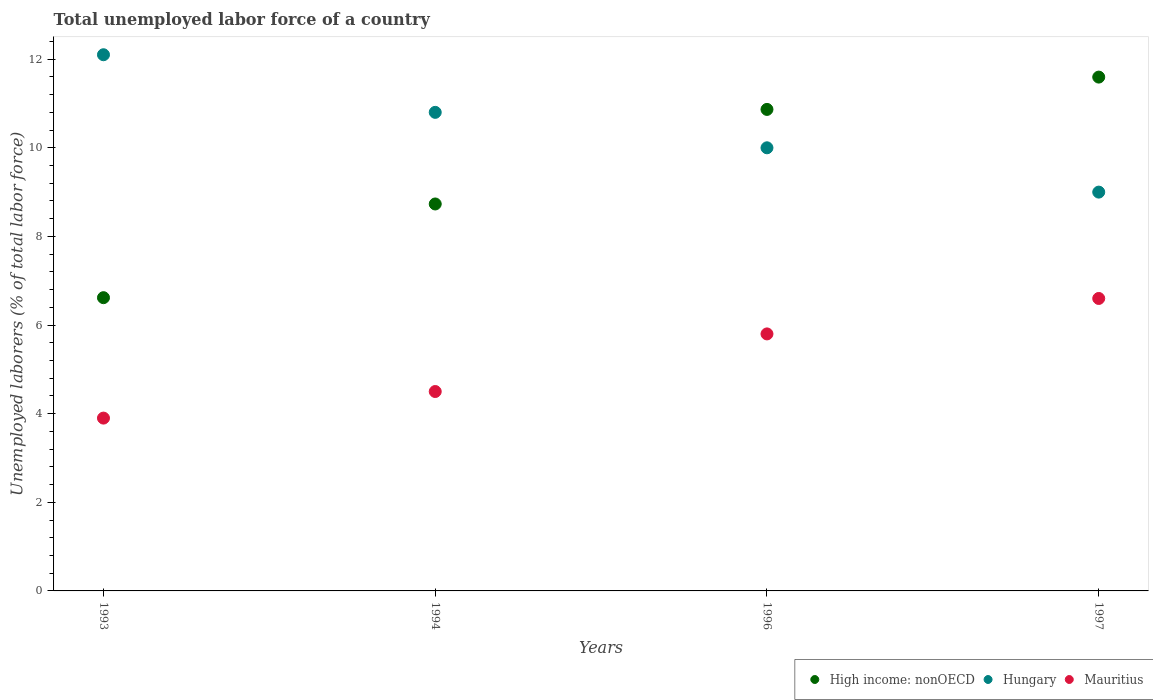How many different coloured dotlines are there?
Give a very brief answer. 3. Is the number of dotlines equal to the number of legend labels?
Your answer should be compact. Yes. What is the total unemployed labor force in High income: nonOECD in 1993?
Your answer should be compact. 6.62. Across all years, what is the maximum total unemployed labor force in Hungary?
Provide a short and direct response. 12.1. Across all years, what is the minimum total unemployed labor force in Mauritius?
Give a very brief answer. 3.9. In which year was the total unemployed labor force in Mauritius minimum?
Keep it short and to the point. 1993. What is the total total unemployed labor force in Hungary in the graph?
Your answer should be compact. 41.9. What is the difference between the total unemployed labor force in High income: nonOECD in 1994 and that in 1996?
Offer a terse response. -2.13. What is the difference between the total unemployed labor force in High income: nonOECD in 1994 and the total unemployed labor force in Mauritius in 1997?
Keep it short and to the point. 2.13. What is the average total unemployed labor force in High income: nonOECD per year?
Give a very brief answer. 9.45. In the year 1993, what is the difference between the total unemployed labor force in High income: nonOECD and total unemployed labor force in Hungary?
Keep it short and to the point. -5.48. In how many years, is the total unemployed labor force in Mauritius greater than 7.2 %?
Offer a terse response. 0. What is the ratio of the total unemployed labor force in Hungary in 1993 to that in 1994?
Ensure brevity in your answer.  1.12. Is the total unemployed labor force in High income: nonOECD in 1993 less than that in 1994?
Ensure brevity in your answer.  Yes. Is the difference between the total unemployed labor force in High income: nonOECD in 1993 and 1996 greater than the difference between the total unemployed labor force in Hungary in 1993 and 1996?
Provide a succinct answer. No. What is the difference between the highest and the second highest total unemployed labor force in Mauritius?
Offer a terse response. 0.8. What is the difference between the highest and the lowest total unemployed labor force in Hungary?
Make the answer very short. 3.1. In how many years, is the total unemployed labor force in Hungary greater than the average total unemployed labor force in Hungary taken over all years?
Ensure brevity in your answer.  2. Is the sum of the total unemployed labor force in Mauritius in 1993 and 1997 greater than the maximum total unemployed labor force in Hungary across all years?
Your answer should be very brief. No. Is it the case that in every year, the sum of the total unemployed labor force in High income: nonOECD and total unemployed labor force in Hungary  is greater than the total unemployed labor force in Mauritius?
Ensure brevity in your answer.  Yes. Does the total unemployed labor force in Hungary monotonically increase over the years?
Your answer should be very brief. No. Is the total unemployed labor force in Hungary strictly less than the total unemployed labor force in Mauritius over the years?
Give a very brief answer. No. How many dotlines are there?
Offer a very short reply. 3. How many years are there in the graph?
Provide a succinct answer. 4. What is the difference between two consecutive major ticks on the Y-axis?
Provide a succinct answer. 2. Are the values on the major ticks of Y-axis written in scientific E-notation?
Provide a short and direct response. No. Does the graph contain grids?
Your answer should be compact. No. Where does the legend appear in the graph?
Make the answer very short. Bottom right. What is the title of the graph?
Give a very brief answer. Total unemployed labor force of a country. Does "Niger" appear as one of the legend labels in the graph?
Your answer should be very brief. No. What is the label or title of the Y-axis?
Provide a short and direct response. Unemployed laborers (% of total labor force). What is the Unemployed laborers (% of total labor force) in High income: nonOECD in 1993?
Ensure brevity in your answer.  6.62. What is the Unemployed laborers (% of total labor force) of Hungary in 1993?
Provide a succinct answer. 12.1. What is the Unemployed laborers (% of total labor force) in Mauritius in 1993?
Give a very brief answer. 3.9. What is the Unemployed laborers (% of total labor force) of High income: nonOECD in 1994?
Keep it short and to the point. 8.73. What is the Unemployed laborers (% of total labor force) in Hungary in 1994?
Ensure brevity in your answer.  10.8. What is the Unemployed laborers (% of total labor force) of Mauritius in 1994?
Give a very brief answer. 4.5. What is the Unemployed laborers (% of total labor force) of High income: nonOECD in 1996?
Keep it short and to the point. 10.87. What is the Unemployed laborers (% of total labor force) in Mauritius in 1996?
Offer a terse response. 5.8. What is the Unemployed laborers (% of total labor force) of High income: nonOECD in 1997?
Keep it short and to the point. 11.6. What is the Unemployed laborers (% of total labor force) of Mauritius in 1997?
Your answer should be very brief. 6.6. Across all years, what is the maximum Unemployed laborers (% of total labor force) in High income: nonOECD?
Provide a short and direct response. 11.6. Across all years, what is the maximum Unemployed laborers (% of total labor force) in Hungary?
Make the answer very short. 12.1. Across all years, what is the maximum Unemployed laborers (% of total labor force) in Mauritius?
Provide a short and direct response. 6.6. Across all years, what is the minimum Unemployed laborers (% of total labor force) of High income: nonOECD?
Your response must be concise. 6.62. Across all years, what is the minimum Unemployed laborers (% of total labor force) in Mauritius?
Make the answer very short. 3.9. What is the total Unemployed laborers (% of total labor force) of High income: nonOECD in the graph?
Offer a very short reply. 37.81. What is the total Unemployed laborers (% of total labor force) of Hungary in the graph?
Make the answer very short. 41.9. What is the total Unemployed laborers (% of total labor force) in Mauritius in the graph?
Your answer should be very brief. 20.8. What is the difference between the Unemployed laborers (% of total labor force) of High income: nonOECD in 1993 and that in 1994?
Your response must be concise. -2.11. What is the difference between the Unemployed laborers (% of total labor force) in Hungary in 1993 and that in 1994?
Give a very brief answer. 1.3. What is the difference between the Unemployed laborers (% of total labor force) in Mauritius in 1993 and that in 1994?
Offer a very short reply. -0.6. What is the difference between the Unemployed laborers (% of total labor force) in High income: nonOECD in 1993 and that in 1996?
Provide a short and direct response. -4.25. What is the difference between the Unemployed laborers (% of total labor force) in Hungary in 1993 and that in 1996?
Your answer should be very brief. 2.1. What is the difference between the Unemployed laborers (% of total labor force) in High income: nonOECD in 1993 and that in 1997?
Give a very brief answer. -4.98. What is the difference between the Unemployed laborers (% of total labor force) of Mauritius in 1993 and that in 1997?
Provide a short and direct response. -2.7. What is the difference between the Unemployed laborers (% of total labor force) in High income: nonOECD in 1994 and that in 1996?
Provide a short and direct response. -2.13. What is the difference between the Unemployed laborers (% of total labor force) of Hungary in 1994 and that in 1996?
Keep it short and to the point. 0.8. What is the difference between the Unemployed laborers (% of total labor force) in High income: nonOECD in 1994 and that in 1997?
Offer a terse response. -2.86. What is the difference between the Unemployed laborers (% of total labor force) in Mauritius in 1994 and that in 1997?
Ensure brevity in your answer.  -2.1. What is the difference between the Unemployed laborers (% of total labor force) of High income: nonOECD in 1996 and that in 1997?
Offer a terse response. -0.73. What is the difference between the Unemployed laborers (% of total labor force) in Hungary in 1996 and that in 1997?
Give a very brief answer. 1. What is the difference between the Unemployed laborers (% of total labor force) of High income: nonOECD in 1993 and the Unemployed laborers (% of total labor force) of Hungary in 1994?
Provide a succinct answer. -4.18. What is the difference between the Unemployed laborers (% of total labor force) of High income: nonOECD in 1993 and the Unemployed laborers (% of total labor force) of Mauritius in 1994?
Provide a short and direct response. 2.12. What is the difference between the Unemployed laborers (% of total labor force) of High income: nonOECD in 1993 and the Unemployed laborers (% of total labor force) of Hungary in 1996?
Keep it short and to the point. -3.38. What is the difference between the Unemployed laborers (% of total labor force) in High income: nonOECD in 1993 and the Unemployed laborers (% of total labor force) in Mauritius in 1996?
Provide a succinct answer. 0.82. What is the difference between the Unemployed laborers (% of total labor force) of Hungary in 1993 and the Unemployed laborers (% of total labor force) of Mauritius in 1996?
Your answer should be compact. 6.3. What is the difference between the Unemployed laborers (% of total labor force) of High income: nonOECD in 1993 and the Unemployed laborers (% of total labor force) of Hungary in 1997?
Your answer should be compact. -2.38. What is the difference between the Unemployed laborers (% of total labor force) in High income: nonOECD in 1993 and the Unemployed laborers (% of total labor force) in Mauritius in 1997?
Give a very brief answer. 0.02. What is the difference between the Unemployed laborers (% of total labor force) in Hungary in 1993 and the Unemployed laborers (% of total labor force) in Mauritius in 1997?
Provide a short and direct response. 5.5. What is the difference between the Unemployed laborers (% of total labor force) of High income: nonOECD in 1994 and the Unemployed laborers (% of total labor force) of Hungary in 1996?
Offer a very short reply. -1.27. What is the difference between the Unemployed laborers (% of total labor force) in High income: nonOECD in 1994 and the Unemployed laborers (% of total labor force) in Mauritius in 1996?
Your answer should be very brief. 2.93. What is the difference between the Unemployed laborers (% of total labor force) in High income: nonOECD in 1994 and the Unemployed laborers (% of total labor force) in Hungary in 1997?
Offer a terse response. -0.27. What is the difference between the Unemployed laborers (% of total labor force) of High income: nonOECD in 1994 and the Unemployed laborers (% of total labor force) of Mauritius in 1997?
Your answer should be very brief. 2.13. What is the difference between the Unemployed laborers (% of total labor force) of Hungary in 1994 and the Unemployed laborers (% of total labor force) of Mauritius in 1997?
Your answer should be compact. 4.2. What is the difference between the Unemployed laborers (% of total labor force) in High income: nonOECD in 1996 and the Unemployed laborers (% of total labor force) in Hungary in 1997?
Give a very brief answer. 1.87. What is the difference between the Unemployed laborers (% of total labor force) in High income: nonOECD in 1996 and the Unemployed laborers (% of total labor force) in Mauritius in 1997?
Provide a short and direct response. 4.27. What is the average Unemployed laborers (% of total labor force) in High income: nonOECD per year?
Offer a very short reply. 9.45. What is the average Unemployed laborers (% of total labor force) of Hungary per year?
Make the answer very short. 10.47. In the year 1993, what is the difference between the Unemployed laborers (% of total labor force) in High income: nonOECD and Unemployed laborers (% of total labor force) in Hungary?
Offer a terse response. -5.48. In the year 1993, what is the difference between the Unemployed laborers (% of total labor force) of High income: nonOECD and Unemployed laborers (% of total labor force) of Mauritius?
Provide a short and direct response. 2.72. In the year 1994, what is the difference between the Unemployed laborers (% of total labor force) in High income: nonOECD and Unemployed laborers (% of total labor force) in Hungary?
Offer a terse response. -2.07. In the year 1994, what is the difference between the Unemployed laborers (% of total labor force) in High income: nonOECD and Unemployed laborers (% of total labor force) in Mauritius?
Offer a terse response. 4.23. In the year 1994, what is the difference between the Unemployed laborers (% of total labor force) of Hungary and Unemployed laborers (% of total labor force) of Mauritius?
Ensure brevity in your answer.  6.3. In the year 1996, what is the difference between the Unemployed laborers (% of total labor force) of High income: nonOECD and Unemployed laborers (% of total labor force) of Hungary?
Provide a short and direct response. 0.87. In the year 1996, what is the difference between the Unemployed laborers (% of total labor force) of High income: nonOECD and Unemployed laborers (% of total labor force) of Mauritius?
Give a very brief answer. 5.07. In the year 1997, what is the difference between the Unemployed laborers (% of total labor force) in High income: nonOECD and Unemployed laborers (% of total labor force) in Hungary?
Your answer should be compact. 2.6. In the year 1997, what is the difference between the Unemployed laborers (% of total labor force) in High income: nonOECD and Unemployed laborers (% of total labor force) in Mauritius?
Provide a short and direct response. 5. What is the ratio of the Unemployed laborers (% of total labor force) of High income: nonOECD in 1993 to that in 1994?
Keep it short and to the point. 0.76. What is the ratio of the Unemployed laborers (% of total labor force) in Hungary in 1993 to that in 1994?
Offer a very short reply. 1.12. What is the ratio of the Unemployed laborers (% of total labor force) of Mauritius in 1993 to that in 1994?
Offer a very short reply. 0.87. What is the ratio of the Unemployed laborers (% of total labor force) of High income: nonOECD in 1993 to that in 1996?
Your answer should be compact. 0.61. What is the ratio of the Unemployed laborers (% of total labor force) of Hungary in 1993 to that in 1996?
Provide a short and direct response. 1.21. What is the ratio of the Unemployed laborers (% of total labor force) in Mauritius in 1993 to that in 1996?
Offer a very short reply. 0.67. What is the ratio of the Unemployed laborers (% of total labor force) in High income: nonOECD in 1993 to that in 1997?
Offer a very short reply. 0.57. What is the ratio of the Unemployed laborers (% of total labor force) of Hungary in 1993 to that in 1997?
Your response must be concise. 1.34. What is the ratio of the Unemployed laborers (% of total labor force) of Mauritius in 1993 to that in 1997?
Provide a short and direct response. 0.59. What is the ratio of the Unemployed laborers (% of total labor force) in High income: nonOECD in 1994 to that in 1996?
Ensure brevity in your answer.  0.8. What is the ratio of the Unemployed laborers (% of total labor force) in Hungary in 1994 to that in 1996?
Provide a succinct answer. 1.08. What is the ratio of the Unemployed laborers (% of total labor force) of Mauritius in 1994 to that in 1996?
Provide a short and direct response. 0.78. What is the ratio of the Unemployed laborers (% of total labor force) in High income: nonOECD in 1994 to that in 1997?
Offer a very short reply. 0.75. What is the ratio of the Unemployed laborers (% of total labor force) of Mauritius in 1994 to that in 1997?
Ensure brevity in your answer.  0.68. What is the ratio of the Unemployed laborers (% of total labor force) of High income: nonOECD in 1996 to that in 1997?
Offer a very short reply. 0.94. What is the ratio of the Unemployed laborers (% of total labor force) in Mauritius in 1996 to that in 1997?
Provide a short and direct response. 0.88. What is the difference between the highest and the second highest Unemployed laborers (% of total labor force) of High income: nonOECD?
Offer a very short reply. 0.73. What is the difference between the highest and the second highest Unemployed laborers (% of total labor force) of Mauritius?
Provide a succinct answer. 0.8. What is the difference between the highest and the lowest Unemployed laborers (% of total labor force) in High income: nonOECD?
Keep it short and to the point. 4.98. What is the difference between the highest and the lowest Unemployed laborers (% of total labor force) in Hungary?
Provide a short and direct response. 3.1. 